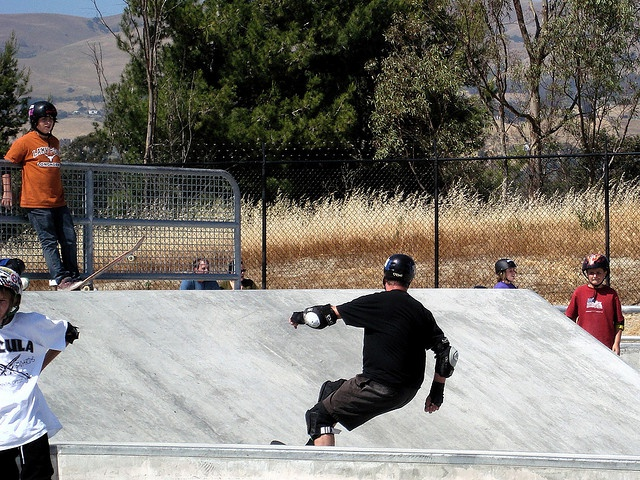Describe the objects in this image and their specific colors. I can see people in darkgray, black, gray, and white tones, people in darkgray, white, and black tones, people in darkgray, black, maroon, brown, and gray tones, people in darkgray, black, brown, and maroon tones, and people in darkgray, gray, black, and maroon tones in this image. 